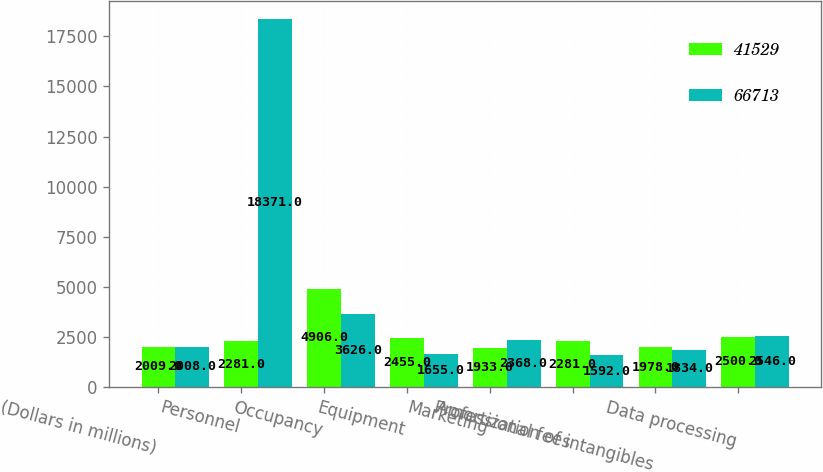Convert chart. <chart><loc_0><loc_0><loc_500><loc_500><stacked_bar_chart><ecel><fcel>(Dollars in millions)<fcel>Personnel<fcel>Occupancy<fcel>Equipment<fcel>Marketing<fcel>Professional fees<fcel>Amortization of intangibles<fcel>Data processing<nl><fcel>41529<fcel>2009<fcel>2281<fcel>4906<fcel>2455<fcel>1933<fcel>2281<fcel>1978<fcel>2500<nl><fcel>66713<fcel>2008<fcel>18371<fcel>3626<fcel>1655<fcel>2368<fcel>1592<fcel>1834<fcel>2546<nl></chart> 